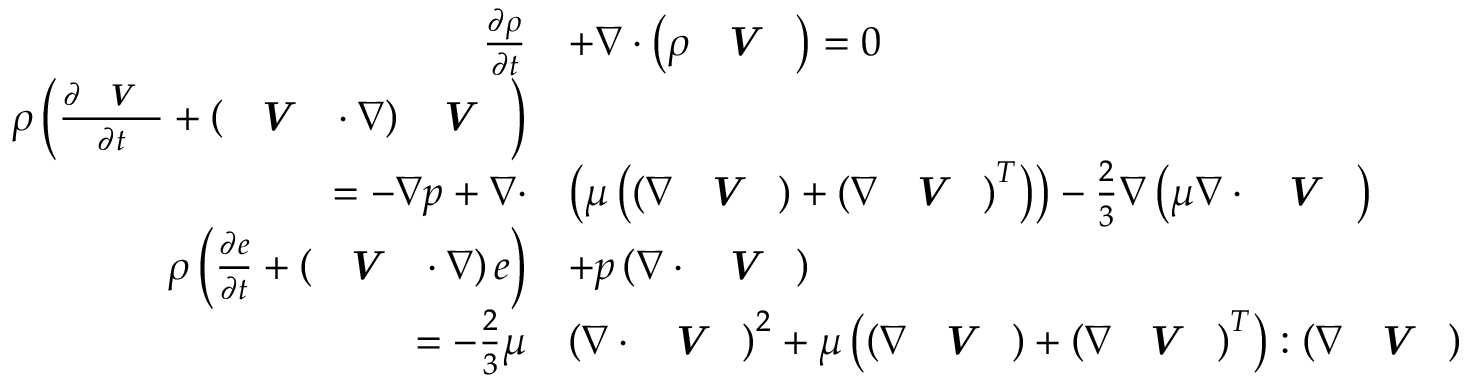Convert formula to latex. <formula><loc_0><loc_0><loc_500><loc_500>\begin{array} { r l } { \frac { \partial \rho } { \partial t } } & { + \nabla \cdot \left ( \rho V \right ) = 0 } \\ { \rho \left ( \frac { \partial V } { \partial t } + \left ( V \cdot \nabla \right ) V \right ) } \\ { = - \nabla p + \nabla \cdot } & { \left ( \mu \left ( \left ( \nabla V \right ) + \left ( \nabla V \right ) ^ { T } \right ) \right ) - \frac { 2 } { 3 } \nabla \left ( \mu \nabla \cdot V \right ) } \\ { \rho \left ( \frac { \partial e } { \partial t } + \left ( V \cdot \nabla \right ) e \right ) } & { + p \left ( \nabla \cdot V \right ) } \\ { = - \frac { 2 } { 3 } \mu } & { \left ( \nabla \cdot V \right ) ^ { 2 } + \mu \left ( \left ( \nabla V \right ) + \left ( \nabla V \right ) ^ { T } \right ) \colon \left ( \nabla V \right ) } \end{array}</formula> 